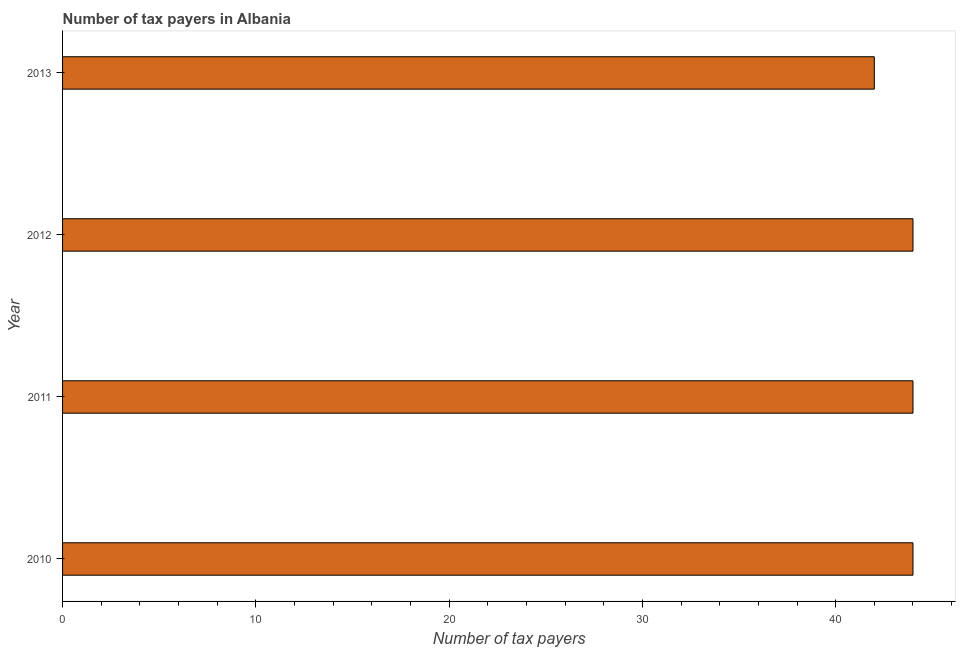What is the title of the graph?
Offer a terse response. Number of tax payers in Albania. What is the label or title of the X-axis?
Offer a very short reply. Number of tax payers. What is the label or title of the Y-axis?
Your answer should be very brief. Year. Across all years, what is the minimum number of tax payers?
Keep it short and to the point. 42. In which year was the number of tax payers maximum?
Your answer should be compact. 2010. In which year was the number of tax payers minimum?
Offer a terse response. 2013. What is the sum of the number of tax payers?
Your answer should be very brief. 174. What is the difference between the number of tax payers in 2012 and 2013?
Give a very brief answer. 2. What is the average number of tax payers per year?
Give a very brief answer. 43. In how many years, is the number of tax payers greater than 6 ?
Your response must be concise. 4. Do a majority of the years between 2011 and 2013 (inclusive) have number of tax payers greater than 36 ?
Your response must be concise. Yes. What is the ratio of the number of tax payers in 2010 to that in 2013?
Provide a short and direct response. 1.05. Is the number of tax payers in 2010 less than that in 2012?
Ensure brevity in your answer.  No. Is the difference between the number of tax payers in 2012 and 2013 greater than the difference between any two years?
Your answer should be compact. Yes. What is the difference between the highest and the second highest number of tax payers?
Keep it short and to the point. 0. Is the sum of the number of tax payers in 2012 and 2013 greater than the maximum number of tax payers across all years?
Keep it short and to the point. Yes. What is the difference between the highest and the lowest number of tax payers?
Provide a succinct answer. 2. Are all the bars in the graph horizontal?
Ensure brevity in your answer.  Yes. What is the difference between two consecutive major ticks on the X-axis?
Your answer should be very brief. 10. What is the Number of tax payers of 2011?
Provide a short and direct response. 44. What is the Number of tax payers of 2012?
Your answer should be compact. 44. What is the Number of tax payers of 2013?
Provide a short and direct response. 42. What is the difference between the Number of tax payers in 2010 and 2011?
Your answer should be very brief. 0. What is the difference between the Number of tax payers in 2011 and 2012?
Keep it short and to the point. 0. What is the difference between the Number of tax payers in 2011 and 2013?
Your answer should be compact. 2. What is the difference between the Number of tax payers in 2012 and 2013?
Keep it short and to the point. 2. What is the ratio of the Number of tax payers in 2010 to that in 2012?
Provide a succinct answer. 1. What is the ratio of the Number of tax payers in 2010 to that in 2013?
Provide a succinct answer. 1.05. What is the ratio of the Number of tax payers in 2011 to that in 2012?
Keep it short and to the point. 1. What is the ratio of the Number of tax payers in 2011 to that in 2013?
Your answer should be compact. 1.05. What is the ratio of the Number of tax payers in 2012 to that in 2013?
Your answer should be very brief. 1.05. 